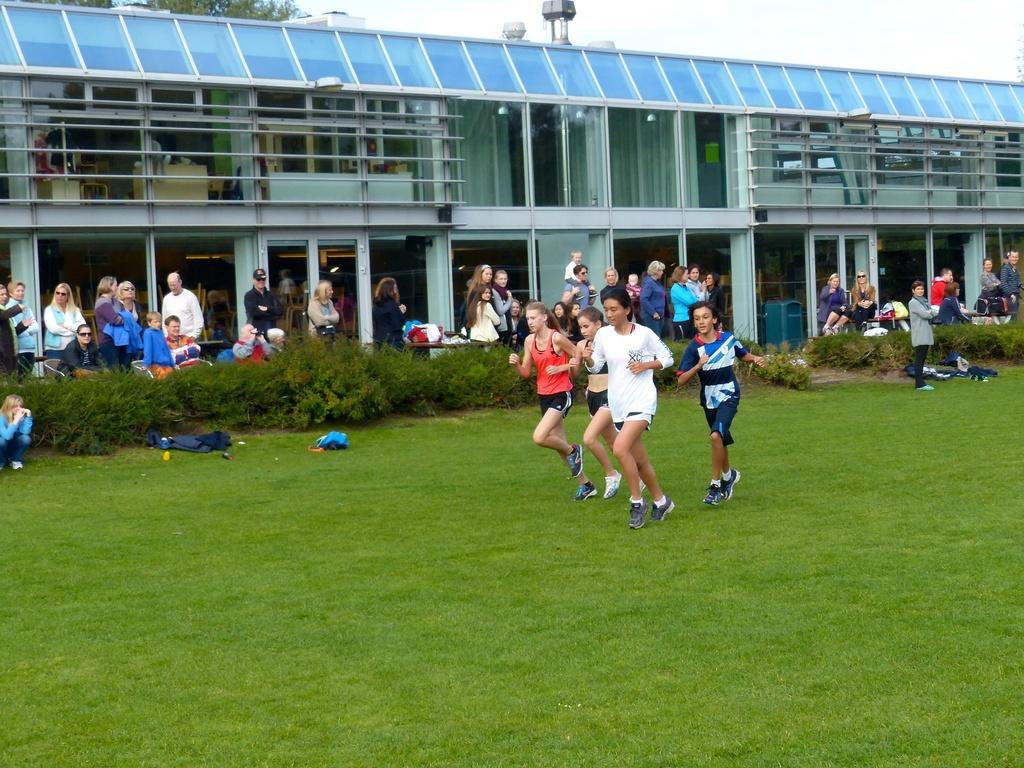Who or what can be seen in the image? There are people in the image. What type of ground surface is visible at the bottom of the image? There is grass at the bottom of the image. What other types of vegetation are present in the image? There are plants in the image. What can be seen in the distance in the image? There is a building and trees in the background of the image. What part of the natural environment is visible in the image? The sky is visible in the image. What else can be seen in the image? There are clothes visible in the image. How many chickens are sitting on the pan in the image? There are no chickens or pans present in the image. 